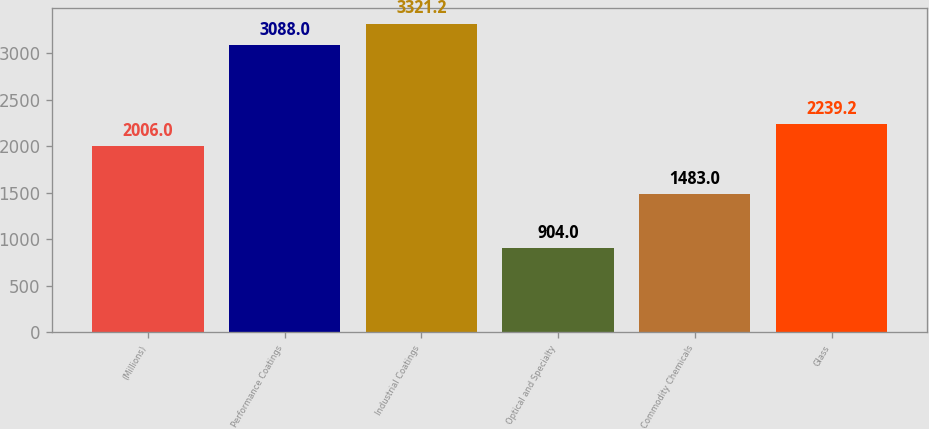Convert chart. <chart><loc_0><loc_0><loc_500><loc_500><bar_chart><fcel>(Millions)<fcel>Performance Coatings<fcel>Industrial Coatings<fcel>Optical and Specialty<fcel>Commodity Chemicals<fcel>Glass<nl><fcel>2006<fcel>3088<fcel>3321.2<fcel>904<fcel>1483<fcel>2239.2<nl></chart> 